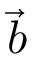Convert formula to latex. <formula><loc_0><loc_0><loc_500><loc_500>\vec { b }</formula> 